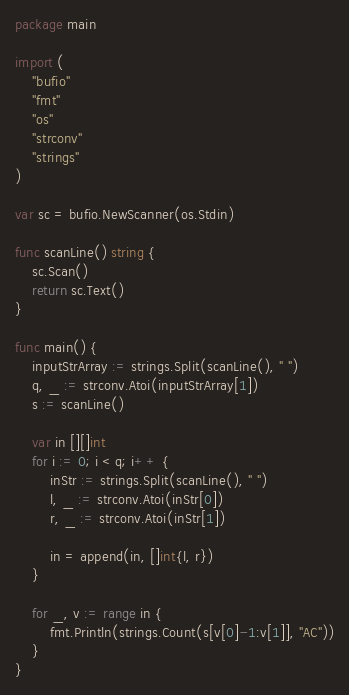Convert code to text. <code><loc_0><loc_0><loc_500><loc_500><_Go_>package main

import (
	"bufio"
	"fmt"
	"os"
	"strconv"
	"strings"
)

var sc = bufio.NewScanner(os.Stdin)

func scanLine() string {
	sc.Scan()
	return sc.Text()
}

func main() {
	inputStrArray := strings.Split(scanLine(), " ")
	q, _ := strconv.Atoi(inputStrArray[1])
	s := scanLine()

	var in [][]int
	for i := 0; i < q; i++ {
		inStr := strings.Split(scanLine(), " ")
		l, _ := strconv.Atoi(inStr[0])
		r, _ := strconv.Atoi(inStr[1])

		in = append(in, []int{l, r})
	}

	for _, v := range in {
		fmt.Println(strings.Count(s[v[0]-1:v[1]], "AC"))
	}
}
</code> 